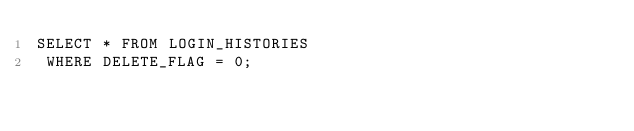<code> <loc_0><loc_0><loc_500><loc_500><_SQL_>SELECT * FROM LOGIN_HISTORIES
 WHERE DELETE_FLAG = 0;
</code> 